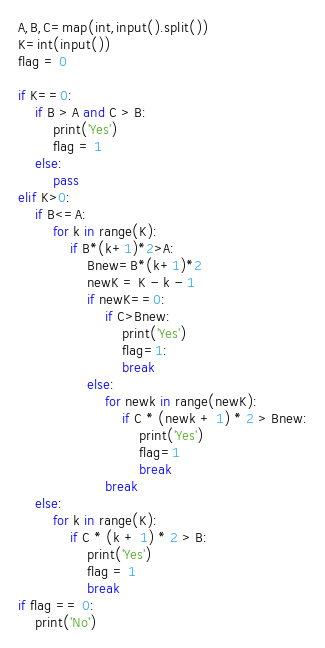<code> <loc_0><loc_0><loc_500><loc_500><_Python_>A,B,C=map(int,input().split())
K=int(input())
flag = 0
 
if K==0:
    if B > A and C > B:
        print('Yes')
        flag = 1
    else:
        pass
elif K>0:
    if B<=A:
        for k in range(K):
            if B*(k+1)*2>A:
                Bnew=B*(k+1)*2
                newK = K - k - 1
                if newK==0:
                    if C>Bnew:
                        print('Yes')
                        flag=1:
                        break
                else:
                    for newk in range(newK):
                        if C * (newk + 1) * 2 > Bnew:
                            print('Yes')
                            flag=1
                            break
                    break
    else:
        for k in range(K):
            if C * (k + 1) * 2 > B:
                print('Yes')
                flag = 1
                break
if flag == 0:
    print('No')</code> 